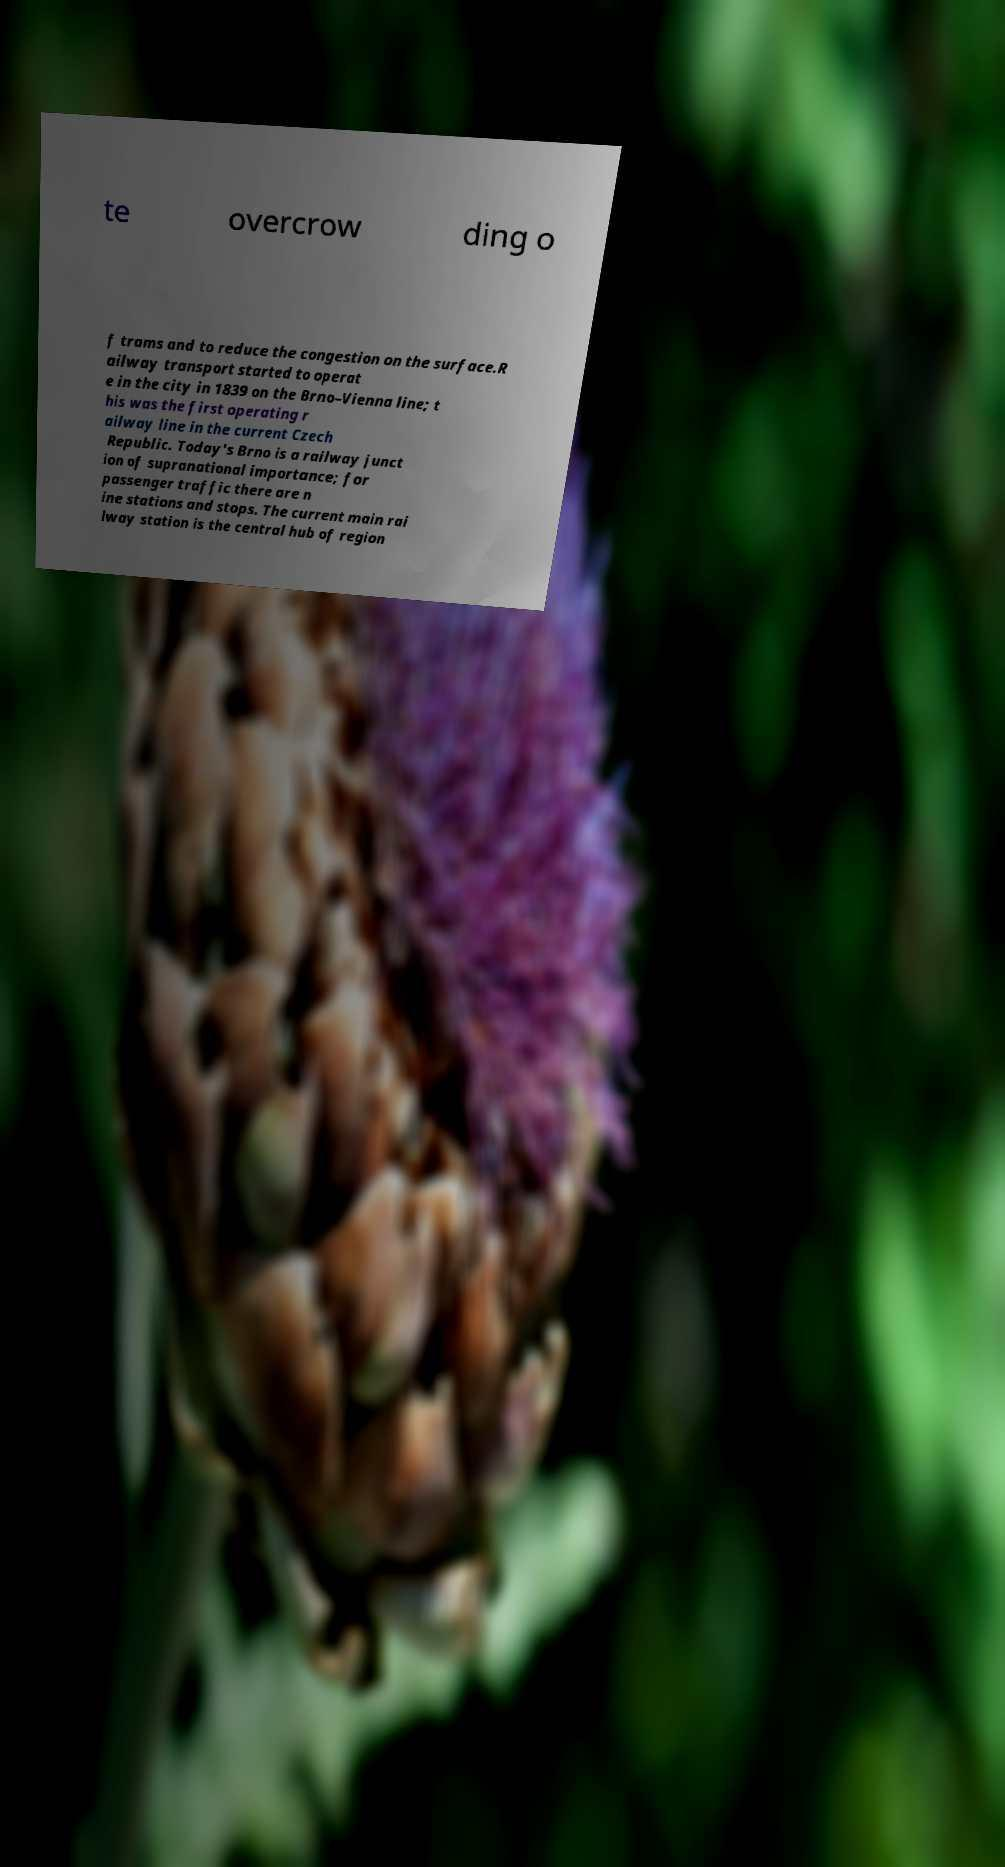Could you assist in decoding the text presented in this image and type it out clearly? te overcrow ding o f trams and to reduce the congestion on the surface.R ailway transport started to operat e in the city in 1839 on the Brno–Vienna line; t his was the first operating r ailway line in the current Czech Republic. Today's Brno is a railway junct ion of supranational importance; for passenger traffic there are n ine stations and stops. The current main rai lway station is the central hub of region 